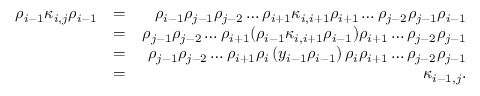<formula> <loc_0><loc_0><loc_500><loc_500>\begin{array} { r l r } { \rho _ { i - 1 } \kappa _ { i , j } \rho _ { i - 1 } } & { = } & { \rho _ { i - 1 } \rho _ { j - 1 } \rho _ { j - 2 } \dots \rho _ { i + 1 } \kappa _ { i , i + 1 } \rho _ { i + 1 } \dots \rho _ { j - 2 } \rho _ { j - 1 } \rho _ { i - 1 } } \\ & { = } & { \rho _ { j - 1 } \rho _ { j - 2 } \dots \rho _ { i + 1 } ( \rho _ { i - 1 } \kappa _ { i , i + 1 } \rho _ { i - 1 } ) \rho _ { i + 1 } \dots \rho _ { j - 2 } \rho _ { j - 1 } } \\ & { = } & { \rho _ { j - 1 } \rho _ { j - 2 } \dots \rho _ { i + 1 } \rho _ { i } \left ( y _ { i - 1 } \rho _ { i - 1 } \right ) \rho _ { i } \rho _ { i + 1 } \dots \rho _ { j - 2 } \rho _ { j - 1 } } \\ & { = } & { \kappa _ { i - 1 , j } . } \end{array}</formula> 